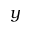Convert formula to latex. <formula><loc_0><loc_0><loc_500><loc_500>y</formula> 